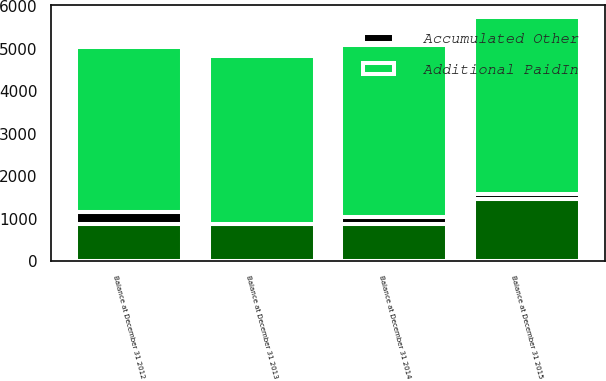Convert chart. <chart><loc_0><loc_0><loc_500><loc_500><stacked_bar_chart><ecel><fcel>Balance at December 31 2012<fcel>Balance at December 31 2013<fcel>Balance at December 31 2014<fcel>Balance at December 31 2015<nl><fcel>nan<fcel>865<fcel>869<fcel>872<fcel>1459<nl><fcel>Additional PaidIn<fcel>3881<fcel>3951<fcel>4050<fcel>4152<nl><fcel>Accumulated Other<fcel>298<fcel>9<fcel>165<fcel>134<nl></chart> 